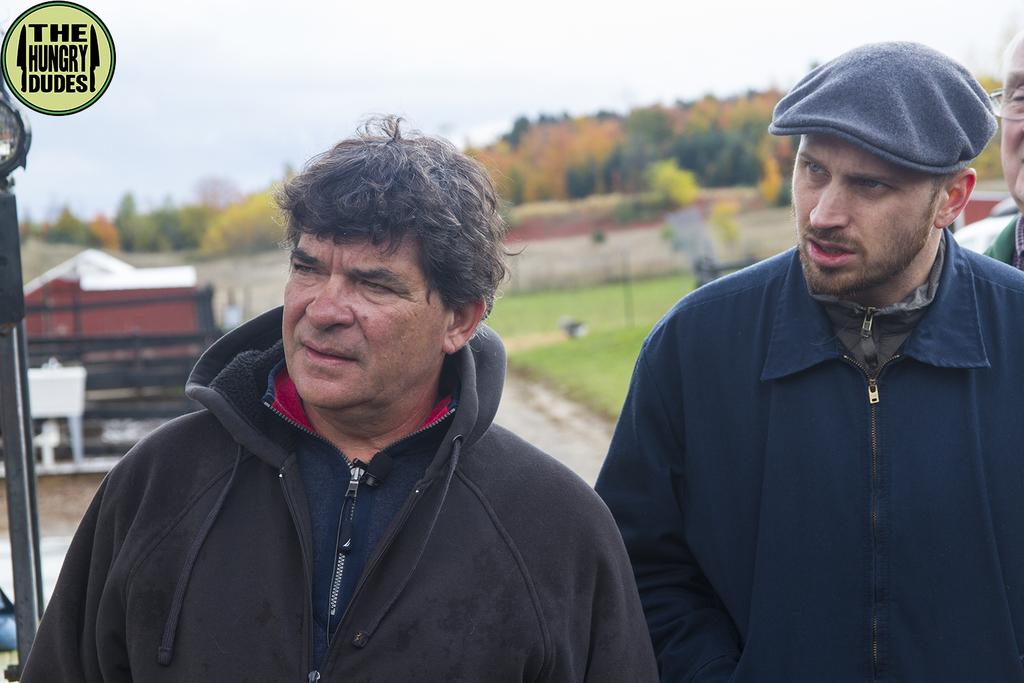How many people are present in the image? There are two persons standing in the image. What can be seen in the background of the image? There is a house with a roof, grass, trees, and the sky visible in the background. What type of vest is the goat wearing in the image? There is no goat present in the image, and therefore no vest can be observed. 